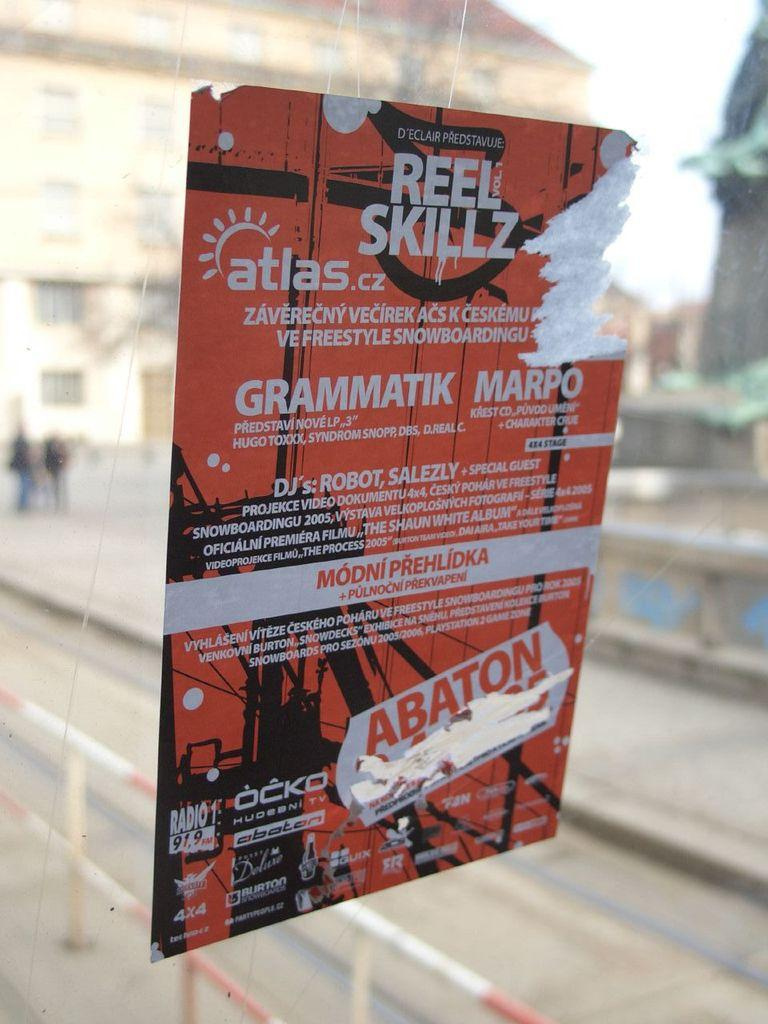Provide a one-sentence caption for the provided image. A poster for an event that is called Reel Skillz. 